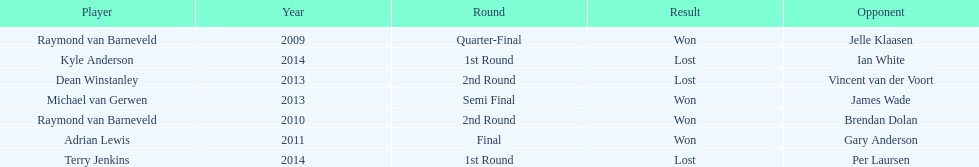Who won the first world darts championship? Raymond van Barneveld. 